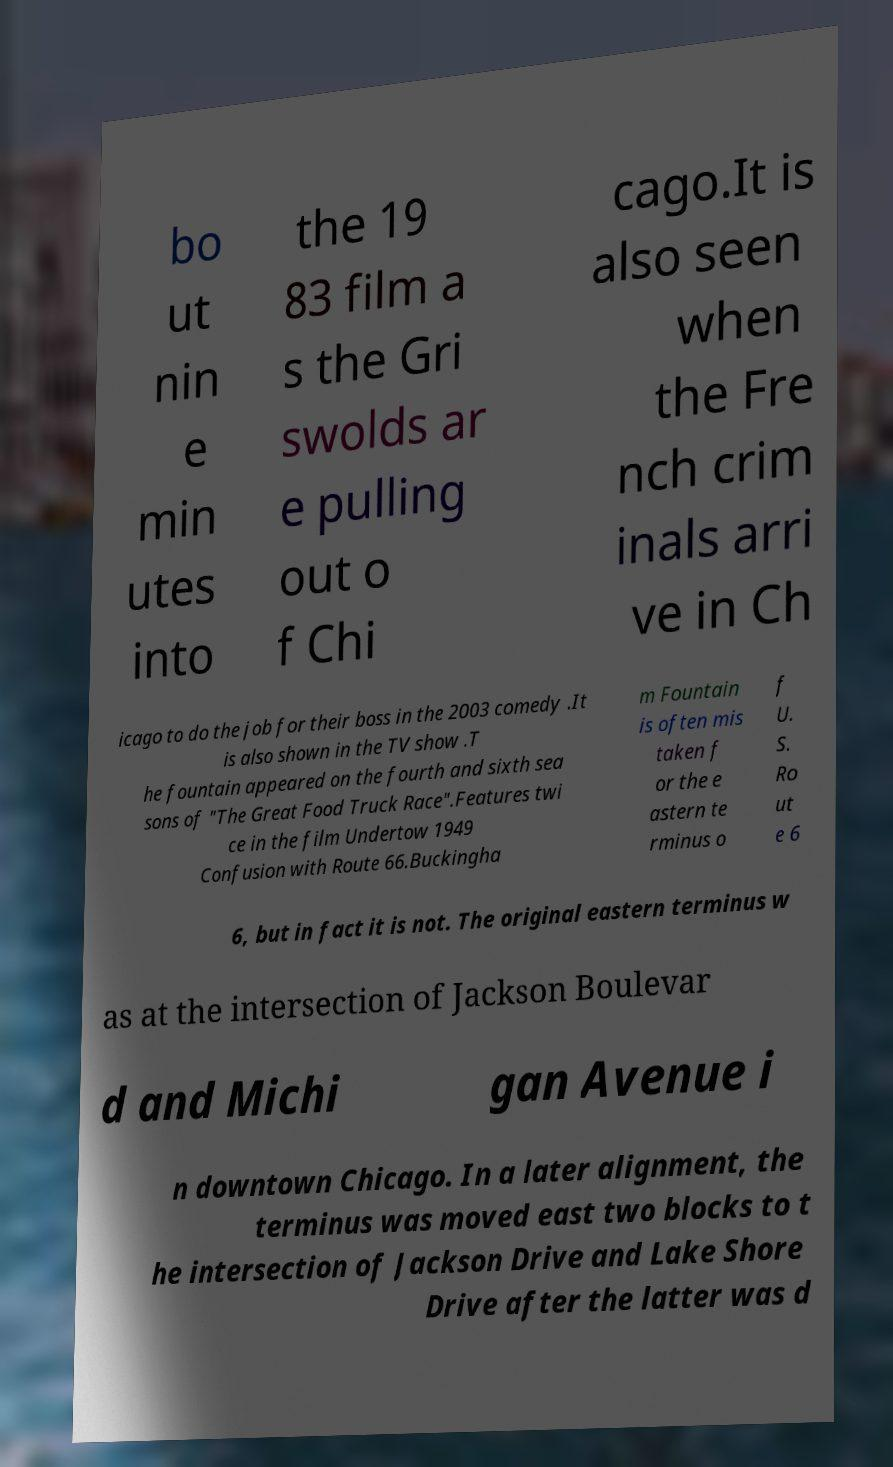Please identify and transcribe the text found in this image. bo ut nin e min utes into the 19 83 film a s the Gri swolds ar e pulling out o f Chi cago.It is also seen when the Fre nch crim inals arri ve in Ch icago to do the job for their boss in the 2003 comedy .It is also shown in the TV show .T he fountain appeared on the fourth and sixth sea sons of "The Great Food Truck Race".Features twi ce in the film Undertow 1949 Confusion with Route 66.Buckingha m Fountain is often mis taken f or the e astern te rminus o f U. S. Ro ut e 6 6, but in fact it is not. The original eastern terminus w as at the intersection of Jackson Boulevar d and Michi gan Avenue i n downtown Chicago. In a later alignment, the terminus was moved east two blocks to t he intersection of Jackson Drive and Lake Shore Drive after the latter was d 